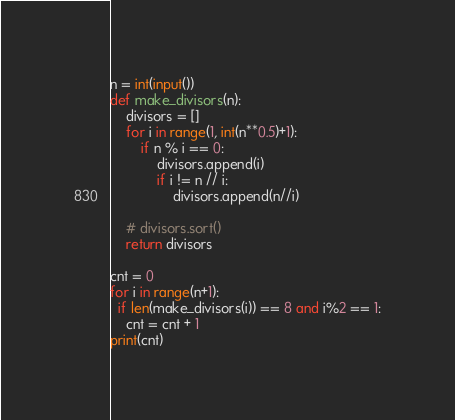<code> <loc_0><loc_0><loc_500><loc_500><_Python_>n = int(input())
def make_divisors(n):
    divisors = []
    for i in range(1, int(n**0.5)+1):
        if n % i == 0:
            divisors.append(i)
            if i != n // i:
                divisors.append(n//i)

    # divisors.sort()
    return divisors

cnt = 0
for i in range(n+1):
  if len(make_divisors(i)) == 8 and i%2 == 1:
    cnt = cnt + 1
print(cnt)</code> 